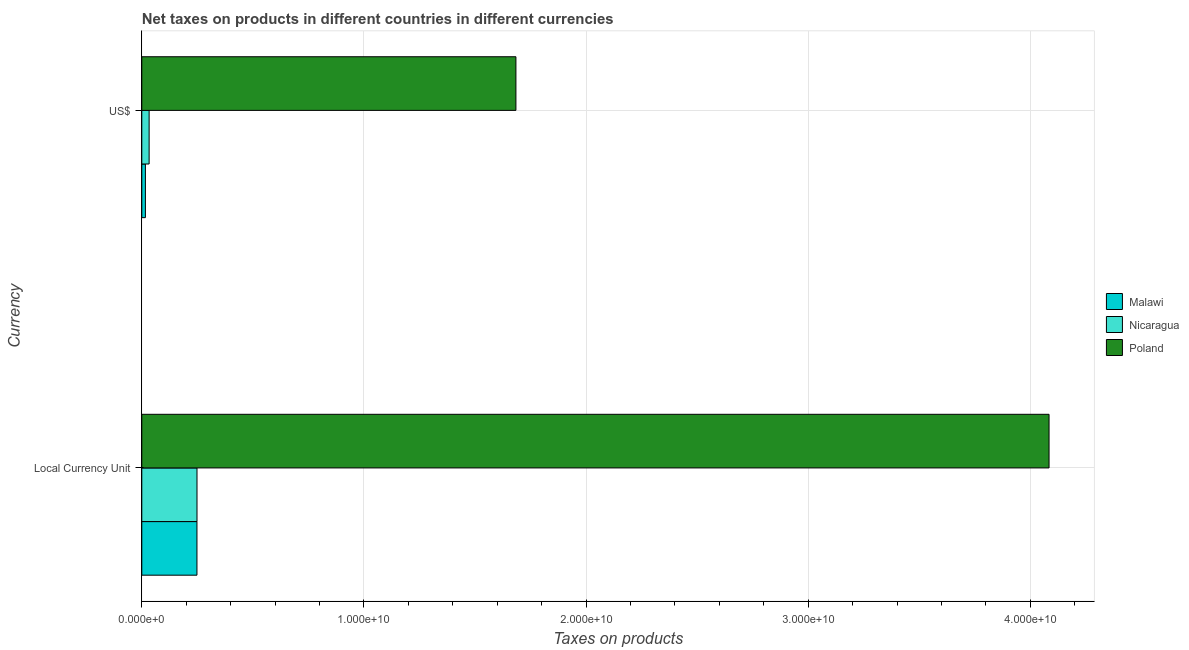How many different coloured bars are there?
Ensure brevity in your answer.  3. Are the number of bars on each tick of the Y-axis equal?
Ensure brevity in your answer.  Yes. What is the label of the 2nd group of bars from the top?
Ensure brevity in your answer.  Local Currency Unit. What is the net taxes in constant 2005 us$ in Malawi?
Your answer should be compact. 2.48e+09. Across all countries, what is the maximum net taxes in constant 2005 us$?
Provide a short and direct response. 4.08e+1. Across all countries, what is the minimum net taxes in constant 2005 us$?
Your answer should be very brief. 2.48e+09. In which country was the net taxes in us$ minimum?
Your answer should be compact. Malawi. What is the total net taxes in constant 2005 us$ in the graph?
Keep it short and to the point. 4.58e+1. What is the difference between the net taxes in constant 2005 us$ in Malawi and that in Poland?
Offer a terse response. -3.84e+1. What is the difference between the net taxes in us$ in Nicaragua and the net taxes in constant 2005 us$ in Poland?
Ensure brevity in your answer.  -4.05e+1. What is the average net taxes in constant 2005 us$ per country?
Offer a terse response. 1.53e+1. What is the difference between the net taxes in us$ and net taxes in constant 2005 us$ in Poland?
Offer a very short reply. -2.40e+1. What is the ratio of the net taxes in us$ in Nicaragua to that in Malawi?
Your answer should be very brief. 2.03. In how many countries, is the net taxes in constant 2005 us$ greater than the average net taxes in constant 2005 us$ taken over all countries?
Offer a very short reply. 1. What does the 3rd bar from the top in Local Currency Unit represents?
Make the answer very short. Malawi. What does the 2nd bar from the bottom in Local Currency Unit represents?
Make the answer very short. Nicaragua. How many countries are there in the graph?
Ensure brevity in your answer.  3. Are the values on the major ticks of X-axis written in scientific E-notation?
Make the answer very short. Yes. Where does the legend appear in the graph?
Offer a terse response. Center right. What is the title of the graph?
Ensure brevity in your answer.  Net taxes on products in different countries in different currencies. What is the label or title of the X-axis?
Ensure brevity in your answer.  Taxes on products. What is the label or title of the Y-axis?
Provide a short and direct response. Currency. What is the Taxes on products of Malawi in Local Currency Unit?
Offer a terse response. 2.48e+09. What is the Taxes on products in Nicaragua in Local Currency Unit?
Provide a succinct answer. 2.49e+09. What is the Taxes on products of Poland in Local Currency Unit?
Your response must be concise. 4.08e+1. What is the Taxes on products in Malawi in US$?
Make the answer very short. 1.62e+08. What is the Taxes on products in Nicaragua in US$?
Ensure brevity in your answer.  3.30e+08. What is the Taxes on products of Poland in US$?
Provide a succinct answer. 1.68e+1. Across all Currency, what is the maximum Taxes on products of Malawi?
Offer a terse response. 2.48e+09. Across all Currency, what is the maximum Taxes on products of Nicaragua?
Provide a succinct answer. 2.49e+09. Across all Currency, what is the maximum Taxes on products of Poland?
Keep it short and to the point. 4.08e+1. Across all Currency, what is the minimum Taxes on products in Malawi?
Provide a short and direct response. 1.62e+08. Across all Currency, what is the minimum Taxes on products of Nicaragua?
Ensure brevity in your answer.  3.30e+08. Across all Currency, what is the minimum Taxes on products of Poland?
Provide a short and direct response. 1.68e+1. What is the total Taxes on products of Malawi in the graph?
Make the answer very short. 2.65e+09. What is the total Taxes on products of Nicaragua in the graph?
Your answer should be very brief. 2.82e+09. What is the total Taxes on products of Poland in the graph?
Make the answer very short. 5.77e+1. What is the difference between the Taxes on products in Malawi in Local Currency Unit and that in US$?
Keep it short and to the point. 2.32e+09. What is the difference between the Taxes on products in Nicaragua in Local Currency Unit and that in US$?
Offer a terse response. 2.16e+09. What is the difference between the Taxes on products in Poland in Local Currency Unit and that in US$?
Give a very brief answer. 2.40e+1. What is the difference between the Taxes on products in Malawi in Local Currency Unit and the Taxes on products in Nicaragua in US$?
Offer a terse response. 2.15e+09. What is the difference between the Taxes on products of Malawi in Local Currency Unit and the Taxes on products of Poland in US$?
Provide a succinct answer. -1.44e+1. What is the difference between the Taxes on products of Nicaragua in Local Currency Unit and the Taxes on products of Poland in US$?
Offer a very short reply. -1.44e+1. What is the average Taxes on products in Malawi per Currency?
Provide a succinct answer. 1.32e+09. What is the average Taxes on products in Nicaragua per Currency?
Your response must be concise. 1.41e+09. What is the average Taxes on products in Poland per Currency?
Offer a very short reply. 2.88e+1. What is the difference between the Taxes on products in Malawi and Taxes on products in Nicaragua in Local Currency Unit?
Provide a succinct answer. -2.18e+06. What is the difference between the Taxes on products of Malawi and Taxes on products of Poland in Local Currency Unit?
Your response must be concise. -3.84e+1. What is the difference between the Taxes on products in Nicaragua and Taxes on products in Poland in Local Currency Unit?
Give a very brief answer. -3.84e+1. What is the difference between the Taxes on products in Malawi and Taxes on products in Nicaragua in US$?
Offer a very short reply. -1.68e+08. What is the difference between the Taxes on products of Malawi and Taxes on products of Poland in US$?
Offer a very short reply. -1.67e+1. What is the difference between the Taxes on products in Nicaragua and Taxes on products in Poland in US$?
Provide a succinct answer. -1.65e+1. What is the ratio of the Taxes on products of Malawi in Local Currency Unit to that in US$?
Keep it short and to the point. 15.28. What is the ratio of the Taxes on products in Nicaragua in Local Currency Unit to that in US$?
Your answer should be compact. 7.53. What is the ratio of the Taxes on products in Poland in Local Currency Unit to that in US$?
Give a very brief answer. 2.42. What is the difference between the highest and the second highest Taxes on products in Malawi?
Your answer should be compact. 2.32e+09. What is the difference between the highest and the second highest Taxes on products of Nicaragua?
Make the answer very short. 2.16e+09. What is the difference between the highest and the second highest Taxes on products in Poland?
Your response must be concise. 2.40e+1. What is the difference between the highest and the lowest Taxes on products in Malawi?
Offer a very short reply. 2.32e+09. What is the difference between the highest and the lowest Taxes on products in Nicaragua?
Offer a very short reply. 2.16e+09. What is the difference between the highest and the lowest Taxes on products in Poland?
Make the answer very short. 2.40e+1. 